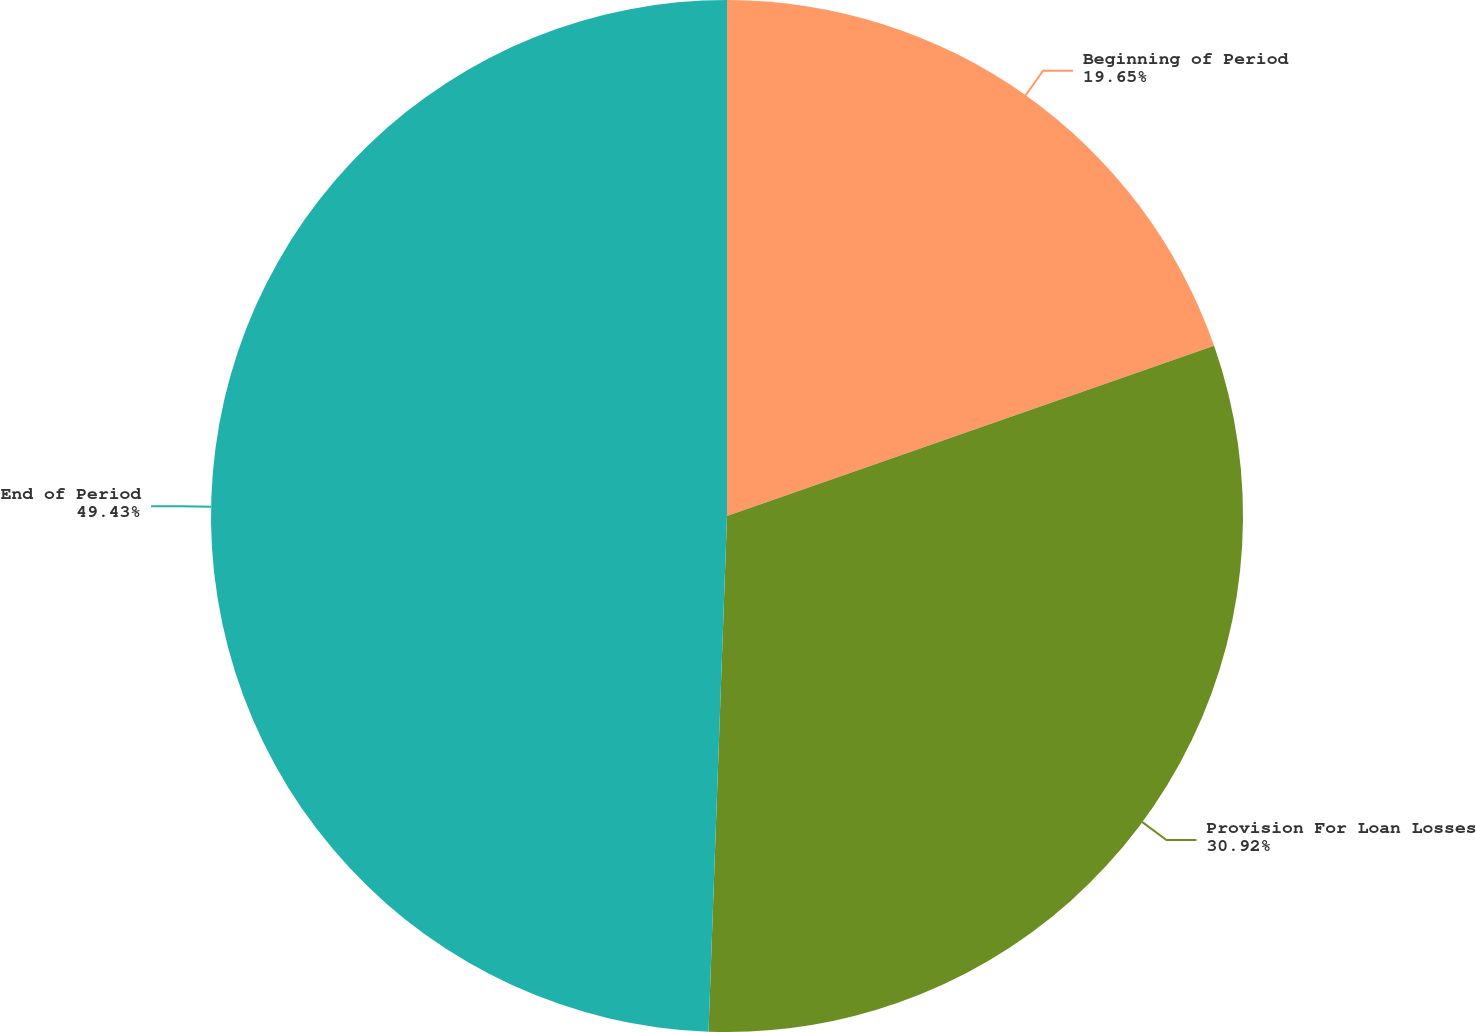Convert chart. <chart><loc_0><loc_0><loc_500><loc_500><pie_chart><fcel>Beginning of Period<fcel>Provision For Loan Losses<fcel>End of Period<nl><fcel>19.65%<fcel>30.92%<fcel>49.43%<nl></chart> 